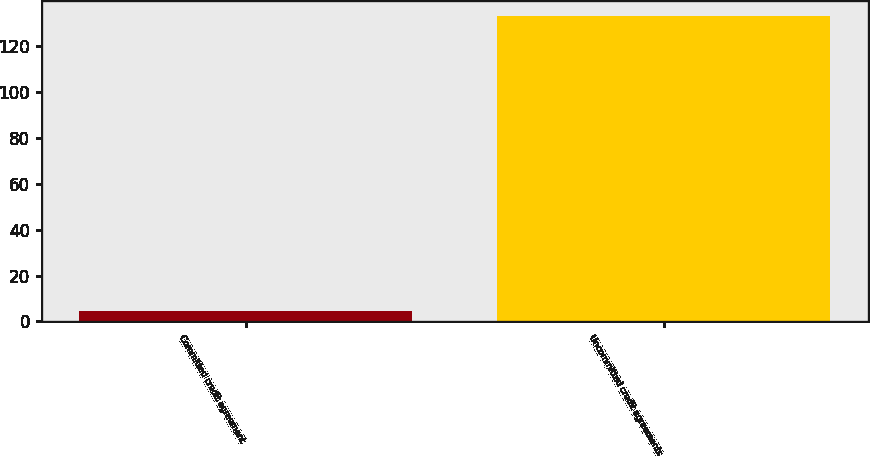Convert chart. <chart><loc_0><loc_0><loc_500><loc_500><bar_chart><fcel>Committed credit agreement<fcel>Uncommitted credit agreements<nl><fcel>4.47<fcel>132.9<nl></chart> 